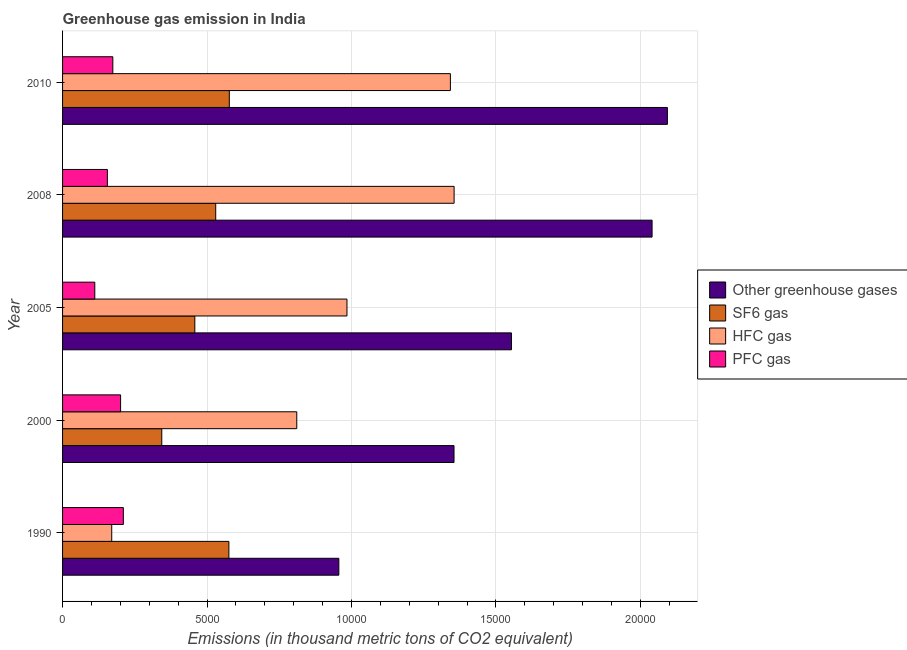What is the emission of sf6 gas in 2008?
Provide a succinct answer. 5301.4. Across all years, what is the maximum emission of pfc gas?
Keep it short and to the point. 2104. Across all years, what is the minimum emission of greenhouse gases?
Ensure brevity in your answer.  9563.6. In which year was the emission of hfc gas maximum?
Your answer should be compact. 2008. In which year was the emission of sf6 gas minimum?
Offer a very short reply. 2000. What is the total emission of sf6 gas in the graph?
Your answer should be very brief. 2.48e+04. What is the difference between the emission of pfc gas in 2000 and that in 2005?
Provide a succinct answer. 893. What is the difference between the emission of sf6 gas in 2000 and the emission of hfc gas in 2008?
Offer a terse response. -1.01e+04. What is the average emission of sf6 gas per year?
Offer a very short reply. 4968.86. In the year 2005, what is the difference between the emission of greenhouse gases and emission of sf6 gas?
Give a very brief answer. 1.10e+04. What is the ratio of the emission of pfc gas in 1990 to that in 2008?
Your response must be concise. 1.36. What is the difference between the highest and the second highest emission of greenhouse gases?
Offer a very short reply. 530.1. What is the difference between the highest and the lowest emission of sf6 gas?
Ensure brevity in your answer.  2337.3. In how many years, is the emission of pfc gas greater than the average emission of pfc gas taken over all years?
Ensure brevity in your answer.  3. Is it the case that in every year, the sum of the emission of pfc gas and emission of hfc gas is greater than the sum of emission of sf6 gas and emission of greenhouse gases?
Give a very brief answer. Yes. What does the 2nd bar from the top in 2010 represents?
Keep it short and to the point. HFC gas. What does the 2nd bar from the bottom in 2000 represents?
Make the answer very short. SF6 gas. How many bars are there?
Your answer should be compact. 20. What is the difference between two consecutive major ticks on the X-axis?
Provide a short and direct response. 5000. How many legend labels are there?
Your response must be concise. 4. How are the legend labels stacked?
Offer a very short reply. Vertical. What is the title of the graph?
Your answer should be compact. Greenhouse gas emission in India. Does "Agriculture" appear as one of the legend labels in the graph?
Make the answer very short. No. What is the label or title of the X-axis?
Provide a short and direct response. Emissions (in thousand metric tons of CO2 equivalent). What is the label or title of the Y-axis?
Your answer should be very brief. Year. What is the Emissions (in thousand metric tons of CO2 equivalent) in Other greenhouse gases in 1990?
Give a very brief answer. 9563.6. What is the Emissions (in thousand metric tons of CO2 equivalent) of SF6 gas in 1990?
Offer a very short reply. 5757.5. What is the Emissions (in thousand metric tons of CO2 equivalent) of HFC gas in 1990?
Provide a succinct answer. 1702.1. What is the Emissions (in thousand metric tons of CO2 equivalent) in PFC gas in 1990?
Ensure brevity in your answer.  2104. What is the Emissions (in thousand metric tons of CO2 equivalent) of Other greenhouse gases in 2000?
Offer a terse response. 1.36e+04. What is the Emissions (in thousand metric tons of CO2 equivalent) of SF6 gas in 2000?
Ensure brevity in your answer.  3434.7. What is the Emissions (in thousand metric tons of CO2 equivalent) of HFC gas in 2000?
Provide a short and direct response. 8107.2. What is the Emissions (in thousand metric tons of CO2 equivalent) in PFC gas in 2000?
Keep it short and to the point. 2008.8. What is the Emissions (in thousand metric tons of CO2 equivalent) of Other greenhouse gases in 2005?
Give a very brief answer. 1.55e+04. What is the Emissions (in thousand metric tons of CO2 equivalent) of SF6 gas in 2005?
Your answer should be compact. 4578.7. What is the Emissions (in thousand metric tons of CO2 equivalent) in HFC gas in 2005?
Provide a short and direct response. 9845.2. What is the Emissions (in thousand metric tons of CO2 equivalent) of PFC gas in 2005?
Your answer should be very brief. 1115.8. What is the Emissions (in thousand metric tons of CO2 equivalent) in Other greenhouse gases in 2008?
Your answer should be compact. 2.04e+04. What is the Emissions (in thousand metric tons of CO2 equivalent) of SF6 gas in 2008?
Keep it short and to the point. 5301.4. What is the Emissions (in thousand metric tons of CO2 equivalent) of HFC gas in 2008?
Provide a succinct answer. 1.36e+04. What is the Emissions (in thousand metric tons of CO2 equivalent) of PFC gas in 2008?
Offer a terse response. 1551.8. What is the Emissions (in thousand metric tons of CO2 equivalent) of Other greenhouse gases in 2010?
Give a very brief answer. 2.09e+04. What is the Emissions (in thousand metric tons of CO2 equivalent) in SF6 gas in 2010?
Ensure brevity in your answer.  5772. What is the Emissions (in thousand metric tons of CO2 equivalent) of HFC gas in 2010?
Offer a very short reply. 1.34e+04. What is the Emissions (in thousand metric tons of CO2 equivalent) in PFC gas in 2010?
Provide a short and direct response. 1740. Across all years, what is the maximum Emissions (in thousand metric tons of CO2 equivalent) in Other greenhouse gases?
Keep it short and to the point. 2.09e+04. Across all years, what is the maximum Emissions (in thousand metric tons of CO2 equivalent) in SF6 gas?
Keep it short and to the point. 5772. Across all years, what is the maximum Emissions (in thousand metric tons of CO2 equivalent) in HFC gas?
Provide a succinct answer. 1.36e+04. Across all years, what is the maximum Emissions (in thousand metric tons of CO2 equivalent) in PFC gas?
Offer a very short reply. 2104. Across all years, what is the minimum Emissions (in thousand metric tons of CO2 equivalent) of Other greenhouse gases?
Provide a short and direct response. 9563.6. Across all years, what is the minimum Emissions (in thousand metric tons of CO2 equivalent) in SF6 gas?
Ensure brevity in your answer.  3434.7. Across all years, what is the minimum Emissions (in thousand metric tons of CO2 equivalent) of HFC gas?
Your answer should be compact. 1702.1. Across all years, what is the minimum Emissions (in thousand metric tons of CO2 equivalent) of PFC gas?
Your answer should be compact. 1115.8. What is the total Emissions (in thousand metric tons of CO2 equivalent) in Other greenhouse gases in the graph?
Give a very brief answer. 8.00e+04. What is the total Emissions (in thousand metric tons of CO2 equivalent) in SF6 gas in the graph?
Give a very brief answer. 2.48e+04. What is the total Emissions (in thousand metric tons of CO2 equivalent) in HFC gas in the graph?
Your answer should be compact. 4.66e+04. What is the total Emissions (in thousand metric tons of CO2 equivalent) of PFC gas in the graph?
Your answer should be compact. 8520.4. What is the difference between the Emissions (in thousand metric tons of CO2 equivalent) of Other greenhouse gases in 1990 and that in 2000?
Give a very brief answer. -3987.1. What is the difference between the Emissions (in thousand metric tons of CO2 equivalent) in SF6 gas in 1990 and that in 2000?
Offer a very short reply. 2322.8. What is the difference between the Emissions (in thousand metric tons of CO2 equivalent) of HFC gas in 1990 and that in 2000?
Your answer should be compact. -6405.1. What is the difference between the Emissions (in thousand metric tons of CO2 equivalent) in PFC gas in 1990 and that in 2000?
Offer a very short reply. 95.2. What is the difference between the Emissions (in thousand metric tons of CO2 equivalent) of Other greenhouse gases in 1990 and that in 2005?
Provide a succinct answer. -5976.1. What is the difference between the Emissions (in thousand metric tons of CO2 equivalent) in SF6 gas in 1990 and that in 2005?
Ensure brevity in your answer.  1178.8. What is the difference between the Emissions (in thousand metric tons of CO2 equivalent) in HFC gas in 1990 and that in 2005?
Offer a very short reply. -8143.1. What is the difference between the Emissions (in thousand metric tons of CO2 equivalent) in PFC gas in 1990 and that in 2005?
Give a very brief answer. 988.2. What is the difference between the Emissions (in thousand metric tons of CO2 equivalent) of Other greenhouse gases in 1990 and that in 2008?
Offer a very short reply. -1.08e+04. What is the difference between the Emissions (in thousand metric tons of CO2 equivalent) in SF6 gas in 1990 and that in 2008?
Provide a short and direct response. 456.1. What is the difference between the Emissions (in thousand metric tons of CO2 equivalent) of HFC gas in 1990 and that in 2008?
Offer a terse response. -1.19e+04. What is the difference between the Emissions (in thousand metric tons of CO2 equivalent) of PFC gas in 1990 and that in 2008?
Your response must be concise. 552.2. What is the difference between the Emissions (in thousand metric tons of CO2 equivalent) in Other greenhouse gases in 1990 and that in 2010?
Give a very brief answer. -1.14e+04. What is the difference between the Emissions (in thousand metric tons of CO2 equivalent) in SF6 gas in 1990 and that in 2010?
Your answer should be very brief. -14.5. What is the difference between the Emissions (in thousand metric tons of CO2 equivalent) in HFC gas in 1990 and that in 2010?
Offer a terse response. -1.17e+04. What is the difference between the Emissions (in thousand metric tons of CO2 equivalent) in PFC gas in 1990 and that in 2010?
Your answer should be very brief. 364. What is the difference between the Emissions (in thousand metric tons of CO2 equivalent) in Other greenhouse gases in 2000 and that in 2005?
Provide a short and direct response. -1989. What is the difference between the Emissions (in thousand metric tons of CO2 equivalent) of SF6 gas in 2000 and that in 2005?
Make the answer very short. -1144. What is the difference between the Emissions (in thousand metric tons of CO2 equivalent) of HFC gas in 2000 and that in 2005?
Give a very brief answer. -1738. What is the difference between the Emissions (in thousand metric tons of CO2 equivalent) of PFC gas in 2000 and that in 2005?
Ensure brevity in your answer.  893. What is the difference between the Emissions (in thousand metric tons of CO2 equivalent) in Other greenhouse gases in 2000 and that in 2008?
Offer a terse response. -6856.2. What is the difference between the Emissions (in thousand metric tons of CO2 equivalent) in SF6 gas in 2000 and that in 2008?
Offer a terse response. -1866.7. What is the difference between the Emissions (in thousand metric tons of CO2 equivalent) in HFC gas in 2000 and that in 2008?
Your response must be concise. -5446.5. What is the difference between the Emissions (in thousand metric tons of CO2 equivalent) in PFC gas in 2000 and that in 2008?
Provide a short and direct response. 457. What is the difference between the Emissions (in thousand metric tons of CO2 equivalent) in Other greenhouse gases in 2000 and that in 2010?
Your response must be concise. -7386.3. What is the difference between the Emissions (in thousand metric tons of CO2 equivalent) of SF6 gas in 2000 and that in 2010?
Keep it short and to the point. -2337.3. What is the difference between the Emissions (in thousand metric tons of CO2 equivalent) in HFC gas in 2000 and that in 2010?
Your answer should be very brief. -5317.8. What is the difference between the Emissions (in thousand metric tons of CO2 equivalent) of PFC gas in 2000 and that in 2010?
Your answer should be very brief. 268.8. What is the difference between the Emissions (in thousand metric tons of CO2 equivalent) in Other greenhouse gases in 2005 and that in 2008?
Offer a very short reply. -4867.2. What is the difference between the Emissions (in thousand metric tons of CO2 equivalent) in SF6 gas in 2005 and that in 2008?
Offer a terse response. -722.7. What is the difference between the Emissions (in thousand metric tons of CO2 equivalent) in HFC gas in 2005 and that in 2008?
Your answer should be very brief. -3708.5. What is the difference between the Emissions (in thousand metric tons of CO2 equivalent) in PFC gas in 2005 and that in 2008?
Your response must be concise. -436. What is the difference between the Emissions (in thousand metric tons of CO2 equivalent) in Other greenhouse gases in 2005 and that in 2010?
Offer a very short reply. -5397.3. What is the difference between the Emissions (in thousand metric tons of CO2 equivalent) in SF6 gas in 2005 and that in 2010?
Provide a short and direct response. -1193.3. What is the difference between the Emissions (in thousand metric tons of CO2 equivalent) of HFC gas in 2005 and that in 2010?
Provide a succinct answer. -3579.8. What is the difference between the Emissions (in thousand metric tons of CO2 equivalent) in PFC gas in 2005 and that in 2010?
Provide a succinct answer. -624.2. What is the difference between the Emissions (in thousand metric tons of CO2 equivalent) of Other greenhouse gases in 2008 and that in 2010?
Your answer should be very brief. -530.1. What is the difference between the Emissions (in thousand metric tons of CO2 equivalent) of SF6 gas in 2008 and that in 2010?
Offer a very short reply. -470.6. What is the difference between the Emissions (in thousand metric tons of CO2 equivalent) in HFC gas in 2008 and that in 2010?
Make the answer very short. 128.7. What is the difference between the Emissions (in thousand metric tons of CO2 equivalent) in PFC gas in 2008 and that in 2010?
Offer a terse response. -188.2. What is the difference between the Emissions (in thousand metric tons of CO2 equivalent) in Other greenhouse gases in 1990 and the Emissions (in thousand metric tons of CO2 equivalent) in SF6 gas in 2000?
Make the answer very short. 6128.9. What is the difference between the Emissions (in thousand metric tons of CO2 equivalent) of Other greenhouse gases in 1990 and the Emissions (in thousand metric tons of CO2 equivalent) of HFC gas in 2000?
Your response must be concise. 1456.4. What is the difference between the Emissions (in thousand metric tons of CO2 equivalent) in Other greenhouse gases in 1990 and the Emissions (in thousand metric tons of CO2 equivalent) in PFC gas in 2000?
Your answer should be compact. 7554.8. What is the difference between the Emissions (in thousand metric tons of CO2 equivalent) of SF6 gas in 1990 and the Emissions (in thousand metric tons of CO2 equivalent) of HFC gas in 2000?
Your response must be concise. -2349.7. What is the difference between the Emissions (in thousand metric tons of CO2 equivalent) in SF6 gas in 1990 and the Emissions (in thousand metric tons of CO2 equivalent) in PFC gas in 2000?
Your response must be concise. 3748.7. What is the difference between the Emissions (in thousand metric tons of CO2 equivalent) of HFC gas in 1990 and the Emissions (in thousand metric tons of CO2 equivalent) of PFC gas in 2000?
Provide a short and direct response. -306.7. What is the difference between the Emissions (in thousand metric tons of CO2 equivalent) of Other greenhouse gases in 1990 and the Emissions (in thousand metric tons of CO2 equivalent) of SF6 gas in 2005?
Offer a very short reply. 4984.9. What is the difference between the Emissions (in thousand metric tons of CO2 equivalent) in Other greenhouse gases in 1990 and the Emissions (in thousand metric tons of CO2 equivalent) in HFC gas in 2005?
Offer a very short reply. -281.6. What is the difference between the Emissions (in thousand metric tons of CO2 equivalent) in Other greenhouse gases in 1990 and the Emissions (in thousand metric tons of CO2 equivalent) in PFC gas in 2005?
Your answer should be very brief. 8447.8. What is the difference between the Emissions (in thousand metric tons of CO2 equivalent) of SF6 gas in 1990 and the Emissions (in thousand metric tons of CO2 equivalent) of HFC gas in 2005?
Offer a very short reply. -4087.7. What is the difference between the Emissions (in thousand metric tons of CO2 equivalent) in SF6 gas in 1990 and the Emissions (in thousand metric tons of CO2 equivalent) in PFC gas in 2005?
Offer a very short reply. 4641.7. What is the difference between the Emissions (in thousand metric tons of CO2 equivalent) in HFC gas in 1990 and the Emissions (in thousand metric tons of CO2 equivalent) in PFC gas in 2005?
Your answer should be very brief. 586.3. What is the difference between the Emissions (in thousand metric tons of CO2 equivalent) in Other greenhouse gases in 1990 and the Emissions (in thousand metric tons of CO2 equivalent) in SF6 gas in 2008?
Provide a succinct answer. 4262.2. What is the difference between the Emissions (in thousand metric tons of CO2 equivalent) in Other greenhouse gases in 1990 and the Emissions (in thousand metric tons of CO2 equivalent) in HFC gas in 2008?
Offer a very short reply. -3990.1. What is the difference between the Emissions (in thousand metric tons of CO2 equivalent) of Other greenhouse gases in 1990 and the Emissions (in thousand metric tons of CO2 equivalent) of PFC gas in 2008?
Keep it short and to the point. 8011.8. What is the difference between the Emissions (in thousand metric tons of CO2 equivalent) in SF6 gas in 1990 and the Emissions (in thousand metric tons of CO2 equivalent) in HFC gas in 2008?
Provide a short and direct response. -7796.2. What is the difference between the Emissions (in thousand metric tons of CO2 equivalent) in SF6 gas in 1990 and the Emissions (in thousand metric tons of CO2 equivalent) in PFC gas in 2008?
Your response must be concise. 4205.7. What is the difference between the Emissions (in thousand metric tons of CO2 equivalent) of HFC gas in 1990 and the Emissions (in thousand metric tons of CO2 equivalent) of PFC gas in 2008?
Keep it short and to the point. 150.3. What is the difference between the Emissions (in thousand metric tons of CO2 equivalent) in Other greenhouse gases in 1990 and the Emissions (in thousand metric tons of CO2 equivalent) in SF6 gas in 2010?
Give a very brief answer. 3791.6. What is the difference between the Emissions (in thousand metric tons of CO2 equivalent) of Other greenhouse gases in 1990 and the Emissions (in thousand metric tons of CO2 equivalent) of HFC gas in 2010?
Your answer should be compact. -3861.4. What is the difference between the Emissions (in thousand metric tons of CO2 equivalent) of Other greenhouse gases in 1990 and the Emissions (in thousand metric tons of CO2 equivalent) of PFC gas in 2010?
Provide a short and direct response. 7823.6. What is the difference between the Emissions (in thousand metric tons of CO2 equivalent) of SF6 gas in 1990 and the Emissions (in thousand metric tons of CO2 equivalent) of HFC gas in 2010?
Ensure brevity in your answer.  -7667.5. What is the difference between the Emissions (in thousand metric tons of CO2 equivalent) in SF6 gas in 1990 and the Emissions (in thousand metric tons of CO2 equivalent) in PFC gas in 2010?
Offer a terse response. 4017.5. What is the difference between the Emissions (in thousand metric tons of CO2 equivalent) of HFC gas in 1990 and the Emissions (in thousand metric tons of CO2 equivalent) of PFC gas in 2010?
Ensure brevity in your answer.  -37.9. What is the difference between the Emissions (in thousand metric tons of CO2 equivalent) in Other greenhouse gases in 2000 and the Emissions (in thousand metric tons of CO2 equivalent) in SF6 gas in 2005?
Provide a succinct answer. 8972. What is the difference between the Emissions (in thousand metric tons of CO2 equivalent) of Other greenhouse gases in 2000 and the Emissions (in thousand metric tons of CO2 equivalent) of HFC gas in 2005?
Keep it short and to the point. 3705.5. What is the difference between the Emissions (in thousand metric tons of CO2 equivalent) of Other greenhouse gases in 2000 and the Emissions (in thousand metric tons of CO2 equivalent) of PFC gas in 2005?
Give a very brief answer. 1.24e+04. What is the difference between the Emissions (in thousand metric tons of CO2 equivalent) in SF6 gas in 2000 and the Emissions (in thousand metric tons of CO2 equivalent) in HFC gas in 2005?
Make the answer very short. -6410.5. What is the difference between the Emissions (in thousand metric tons of CO2 equivalent) of SF6 gas in 2000 and the Emissions (in thousand metric tons of CO2 equivalent) of PFC gas in 2005?
Ensure brevity in your answer.  2318.9. What is the difference between the Emissions (in thousand metric tons of CO2 equivalent) in HFC gas in 2000 and the Emissions (in thousand metric tons of CO2 equivalent) in PFC gas in 2005?
Give a very brief answer. 6991.4. What is the difference between the Emissions (in thousand metric tons of CO2 equivalent) of Other greenhouse gases in 2000 and the Emissions (in thousand metric tons of CO2 equivalent) of SF6 gas in 2008?
Your answer should be very brief. 8249.3. What is the difference between the Emissions (in thousand metric tons of CO2 equivalent) in Other greenhouse gases in 2000 and the Emissions (in thousand metric tons of CO2 equivalent) in PFC gas in 2008?
Make the answer very short. 1.20e+04. What is the difference between the Emissions (in thousand metric tons of CO2 equivalent) of SF6 gas in 2000 and the Emissions (in thousand metric tons of CO2 equivalent) of HFC gas in 2008?
Provide a succinct answer. -1.01e+04. What is the difference between the Emissions (in thousand metric tons of CO2 equivalent) in SF6 gas in 2000 and the Emissions (in thousand metric tons of CO2 equivalent) in PFC gas in 2008?
Provide a short and direct response. 1882.9. What is the difference between the Emissions (in thousand metric tons of CO2 equivalent) in HFC gas in 2000 and the Emissions (in thousand metric tons of CO2 equivalent) in PFC gas in 2008?
Make the answer very short. 6555.4. What is the difference between the Emissions (in thousand metric tons of CO2 equivalent) of Other greenhouse gases in 2000 and the Emissions (in thousand metric tons of CO2 equivalent) of SF6 gas in 2010?
Provide a succinct answer. 7778.7. What is the difference between the Emissions (in thousand metric tons of CO2 equivalent) in Other greenhouse gases in 2000 and the Emissions (in thousand metric tons of CO2 equivalent) in HFC gas in 2010?
Your response must be concise. 125.7. What is the difference between the Emissions (in thousand metric tons of CO2 equivalent) of Other greenhouse gases in 2000 and the Emissions (in thousand metric tons of CO2 equivalent) of PFC gas in 2010?
Ensure brevity in your answer.  1.18e+04. What is the difference between the Emissions (in thousand metric tons of CO2 equivalent) in SF6 gas in 2000 and the Emissions (in thousand metric tons of CO2 equivalent) in HFC gas in 2010?
Ensure brevity in your answer.  -9990.3. What is the difference between the Emissions (in thousand metric tons of CO2 equivalent) in SF6 gas in 2000 and the Emissions (in thousand metric tons of CO2 equivalent) in PFC gas in 2010?
Offer a very short reply. 1694.7. What is the difference between the Emissions (in thousand metric tons of CO2 equivalent) in HFC gas in 2000 and the Emissions (in thousand metric tons of CO2 equivalent) in PFC gas in 2010?
Offer a terse response. 6367.2. What is the difference between the Emissions (in thousand metric tons of CO2 equivalent) in Other greenhouse gases in 2005 and the Emissions (in thousand metric tons of CO2 equivalent) in SF6 gas in 2008?
Your response must be concise. 1.02e+04. What is the difference between the Emissions (in thousand metric tons of CO2 equivalent) in Other greenhouse gases in 2005 and the Emissions (in thousand metric tons of CO2 equivalent) in HFC gas in 2008?
Offer a terse response. 1986. What is the difference between the Emissions (in thousand metric tons of CO2 equivalent) of Other greenhouse gases in 2005 and the Emissions (in thousand metric tons of CO2 equivalent) of PFC gas in 2008?
Your answer should be compact. 1.40e+04. What is the difference between the Emissions (in thousand metric tons of CO2 equivalent) in SF6 gas in 2005 and the Emissions (in thousand metric tons of CO2 equivalent) in HFC gas in 2008?
Your answer should be very brief. -8975. What is the difference between the Emissions (in thousand metric tons of CO2 equivalent) in SF6 gas in 2005 and the Emissions (in thousand metric tons of CO2 equivalent) in PFC gas in 2008?
Your response must be concise. 3026.9. What is the difference between the Emissions (in thousand metric tons of CO2 equivalent) in HFC gas in 2005 and the Emissions (in thousand metric tons of CO2 equivalent) in PFC gas in 2008?
Make the answer very short. 8293.4. What is the difference between the Emissions (in thousand metric tons of CO2 equivalent) of Other greenhouse gases in 2005 and the Emissions (in thousand metric tons of CO2 equivalent) of SF6 gas in 2010?
Your answer should be compact. 9767.7. What is the difference between the Emissions (in thousand metric tons of CO2 equivalent) in Other greenhouse gases in 2005 and the Emissions (in thousand metric tons of CO2 equivalent) in HFC gas in 2010?
Keep it short and to the point. 2114.7. What is the difference between the Emissions (in thousand metric tons of CO2 equivalent) of Other greenhouse gases in 2005 and the Emissions (in thousand metric tons of CO2 equivalent) of PFC gas in 2010?
Your answer should be compact. 1.38e+04. What is the difference between the Emissions (in thousand metric tons of CO2 equivalent) of SF6 gas in 2005 and the Emissions (in thousand metric tons of CO2 equivalent) of HFC gas in 2010?
Provide a short and direct response. -8846.3. What is the difference between the Emissions (in thousand metric tons of CO2 equivalent) in SF6 gas in 2005 and the Emissions (in thousand metric tons of CO2 equivalent) in PFC gas in 2010?
Provide a succinct answer. 2838.7. What is the difference between the Emissions (in thousand metric tons of CO2 equivalent) in HFC gas in 2005 and the Emissions (in thousand metric tons of CO2 equivalent) in PFC gas in 2010?
Make the answer very short. 8105.2. What is the difference between the Emissions (in thousand metric tons of CO2 equivalent) in Other greenhouse gases in 2008 and the Emissions (in thousand metric tons of CO2 equivalent) in SF6 gas in 2010?
Your answer should be compact. 1.46e+04. What is the difference between the Emissions (in thousand metric tons of CO2 equivalent) of Other greenhouse gases in 2008 and the Emissions (in thousand metric tons of CO2 equivalent) of HFC gas in 2010?
Offer a very short reply. 6981.9. What is the difference between the Emissions (in thousand metric tons of CO2 equivalent) in Other greenhouse gases in 2008 and the Emissions (in thousand metric tons of CO2 equivalent) in PFC gas in 2010?
Provide a short and direct response. 1.87e+04. What is the difference between the Emissions (in thousand metric tons of CO2 equivalent) in SF6 gas in 2008 and the Emissions (in thousand metric tons of CO2 equivalent) in HFC gas in 2010?
Provide a succinct answer. -8123.6. What is the difference between the Emissions (in thousand metric tons of CO2 equivalent) of SF6 gas in 2008 and the Emissions (in thousand metric tons of CO2 equivalent) of PFC gas in 2010?
Offer a terse response. 3561.4. What is the difference between the Emissions (in thousand metric tons of CO2 equivalent) of HFC gas in 2008 and the Emissions (in thousand metric tons of CO2 equivalent) of PFC gas in 2010?
Provide a short and direct response. 1.18e+04. What is the average Emissions (in thousand metric tons of CO2 equivalent) in Other greenhouse gases per year?
Offer a very short reply. 1.60e+04. What is the average Emissions (in thousand metric tons of CO2 equivalent) of SF6 gas per year?
Your answer should be very brief. 4968.86. What is the average Emissions (in thousand metric tons of CO2 equivalent) in HFC gas per year?
Your answer should be very brief. 9326.64. What is the average Emissions (in thousand metric tons of CO2 equivalent) of PFC gas per year?
Provide a short and direct response. 1704.08. In the year 1990, what is the difference between the Emissions (in thousand metric tons of CO2 equivalent) of Other greenhouse gases and Emissions (in thousand metric tons of CO2 equivalent) of SF6 gas?
Give a very brief answer. 3806.1. In the year 1990, what is the difference between the Emissions (in thousand metric tons of CO2 equivalent) in Other greenhouse gases and Emissions (in thousand metric tons of CO2 equivalent) in HFC gas?
Make the answer very short. 7861.5. In the year 1990, what is the difference between the Emissions (in thousand metric tons of CO2 equivalent) of Other greenhouse gases and Emissions (in thousand metric tons of CO2 equivalent) of PFC gas?
Offer a very short reply. 7459.6. In the year 1990, what is the difference between the Emissions (in thousand metric tons of CO2 equivalent) in SF6 gas and Emissions (in thousand metric tons of CO2 equivalent) in HFC gas?
Offer a terse response. 4055.4. In the year 1990, what is the difference between the Emissions (in thousand metric tons of CO2 equivalent) of SF6 gas and Emissions (in thousand metric tons of CO2 equivalent) of PFC gas?
Offer a terse response. 3653.5. In the year 1990, what is the difference between the Emissions (in thousand metric tons of CO2 equivalent) of HFC gas and Emissions (in thousand metric tons of CO2 equivalent) of PFC gas?
Provide a short and direct response. -401.9. In the year 2000, what is the difference between the Emissions (in thousand metric tons of CO2 equivalent) of Other greenhouse gases and Emissions (in thousand metric tons of CO2 equivalent) of SF6 gas?
Your answer should be very brief. 1.01e+04. In the year 2000, what is the difference between the Emissions (in thousand metric tons of CO2 equivalent) of Other greenhouse gases and Emissions (in thousand metric tons of CO2 equivalent) of HFC gas?
Your answer should be compact. 5443.5. In the year 2000, what is the difference between the Emissions (in thousand metric tons of CO2 equivalent) in Other greenhouse gases and Emissions (in thousand metric tons of CO2 equivalent) in PFC gas?
Your response must be concise. 1.15e+04. In the year 2000, what is the difference between the Emissions (in thousand metric tons of CO2 equivalent) of SF6 gas and Emissions (in thousand metric tons of CO2 equivalent) of HFC gas?
Make the answer very short. -4672.5. In the year 2000, what is the difference between the Emissions (in thousand metric tons of CO2 equivalent) in SF6 gas and Emissions (in thousand metric tons of CO2 equivalent) in PFC gas?
Offer a very short reply. 1425.9. In the year 2000, what is the difference between the Emissions (in thousand metric tons of CO2 equivalent) of HFC gas and Emissions (in thousand metric tons of CO2 equivalent) of PFC gas?
Give a very brief answer. 6098.4. In the year 2005, what is the difference between the Emissions (in thousand metric tons of CO2 equivalent) of Other greenhouse gases and Emissions (in thousand metric tons of CO2 equivalent) of SF6 gas?
Keep it short and to the point. 1.10e+04. In the year 2005, what is the difference between the Emissions (in thousand metric tons of CO2 equivalent) in Other greenhouse gases and Emissions (in thousand metric tons of CO2 equivalent) in HFC gas?
Keep it short and to the point. 5694.5. In the year 2005, what is the difference between the Emissions (in thousand metric tons of CO2 equivalent) of Other greenhouse gases and Emissions (in thousand metric tons of CO2 equivalent) of PFC gas?
Your answer should be very brief. 1.44e+04. In the year 2005, what is the difference between the Emissions (in thousand metric tons of CO2 equivalent) of SF6 gas and Emissions (in thousand metric tons of CO2 equivalent) of HFC gas?
Offer a terse response. -5266.5. In the year 2005, what is the difference between the Emissions (in thousand metric tons of CO2 equivalent) of SF6 gas and Emissions (in thousand metric tons of CO2 equivalent) of PFC gas?
Your response must be concise. 3462.9. In the year 2005, what is the difference between the Emissions (in thousand metric tons of CO2 equivalent) in HFC gas and Emissions (in thousand metric tons of CO2 equivalent) in PFC gas?
Offer a very short reply. 8729.4. In the year 2008, what is the difference between the Emissions (in thousand metric tons of CO2 equivalent) of Other greenhouse gases and Emissions (in thousand metric tons of CO2 equivalent) of SF6 gas?
Your answer should be very brief. 1.51e+04. In the year 2008, what is the difference between the Emissions (in thousand metric tons of CO2 equivalent) in Other greenhouse gases and Emissions (in thousand metric tons of CO2 equivalent) in HFC gas?
Make the answer very short. 6853.2. In the year 2008, what is the difference between the Emissions (in thousand metric tons of CO2 equivalent) of Other greenhouse gases and Emissions (in thousand metric tons of CO2 equivalent) of PFC gas?
Your answer should be very brief. 1.89e+04. In the year 2008, what is the difference between the Emissions (in thousand metric tons of CO2 equivalent) of SF6 gas and Emissions (in thousand metric tons of CO2 equivalent) of HFC gas?
Offer a very short reply. -8252.3. In the year 2008, what is the difference between the Emissions (in thousand metric tons of CO2 equivalent) in SF6 gas and Emissions (in thousand metric tons of CO2 equivalent) in PFC gas?
Your answer should be compact. 3749.6. In the year 2008, what is the difference between the Emissions (in thousand metric tons of CO2 equivalent) in HFC gas and Emissions (in thousand metric tons of CO2 equivalent) in PFC gas?
Provide a succinct answer. 1.20e+04. In the year 2010, what is the difference between the Emissions (in thousand metric tons of CO2 equivalent) in Other greenhouse gases and Emissions (in thousand metric tons of CO2 equivalent) in SF6 gas?
Your response must be concise. 1.52e+04. In the year 2010, what is the difference between the Emissions (in thousand metric tons of CO2 equivalent) in Other greenhouse gases and Emissions (in thousand metric tons of CO2 equivalent) in HFC gas?
Offer a very short reply. 7512. In the year 2010, what is the difference between the Emissions (in thousand metric tons of CO2 equivalent) in Other greenhouse gases and Emissions (in thousand metric tons of CO2 equivalent) in PFC gas?
Your response must be concise. 1.92e+04. In the year 2010, what is the difference between the Emissions (in thousand metric tons of CO2 equivalent) in SF6 gas and Emissions (in thousand metric tons of CO2 equivalent) in HFC gas?
Give a very brief answer. -7653. In the year 2010, what is the difference between the Emissions (in thousand metric tons of CO2 equivalent) of SF6 gas and Emissions (in thousand metric tons of CO2 equivalent) of PFC gas?
Give a very brief answer. 4032. In the year 2010, what is the difference between the Emissions (in thousand metric tons of CO2 equivalent) of HFC gas and Emissions (in thousand metric tons of CO2 equivalent) of PFC gas?
Provide a short and direct response. 1.17e+04. What is the ratio of the Emissions (in thousand metric tons of CO2 equivalent) of Other greenhouse gases in 1990 to that in 2000?
Provide a succinct answer. 0.71. What is the ratio of the Emissions (in thousand metric tons of CO2 equivalent) of SF6 gas in 1990 to that in 2000?
Your answer should be compact. 1.68. What is the ratio of the Emissions (in thousand metric tons of CO2 equivalent) of HFC gas in 1990 to that in 2000?
Make the answer very short. 0.21. What is the ratio of the Emissions (in thousand metric tons of CO2 equivalent) in PFC gas in 1990 to that in 2000?
Your answer should be very brief. 1.05. What is the ratio of the Emissions (in thousand metric tons of CO2 equivalent) in Other greenhouse gases in 1990 to that in 2005?
Give a very brief answer. 0.62. What is the ratio of the Emissions (in thousand metric tons of CO2 equivalent) in SF6 gas in 1990 to that in 2005?
Your response must be concise. 1.26. What is the ratio of the Emissions (in thousand metric tons of CO2 equivalent) in HFC gas in 1990 to that in 2005?
Your answer should be very brief. 0.17. What is the ratio of the Emissions (in thousand metric tons of CO2 equivalent) in PFC gas in 1990 to that in 2005?
Keep it short and to the point. 1.89. What is the ratio of the Emissions (in thousand metric tons of CO2 equivalent) of Other greenhouse gases in 1990 to that in 2008?
Provide a succinct answer. 0.47. What is the ratio of the Emissions (in thousand metric tons of CO2 equivalent) of SF6 gas in 1990 to that in 2008?
Make the answer very short. 1.09. What is the ratio of the Emissions (in thousand metric tons of CO2 equivalent) of HFC gas in 1990 to that in 2008?
Give a very brief answer. 0.13. What is the ratio of the Emissions (in thousand metric tons of CO2 equivalent) of PFC gas in 1990 to that in 2008?
Provide a short and direct response. 1.36. What is the ratio of the Emissions (in thousand metric tons of CO2 equivalent) in Other greenhouse gases in 1990 to that in 2010?
Offer a very short reply. 0.46. What is the ratio of the Emissions (in thousand metric tons of CO2 equivalent) of SF6 gas in 1990 to that in 2010?
Offer a terse response. 1. What is the ratio of the Emissions (in thousand metric tons of CO2 equivalent) of HFC gas in 1990 to that in 2010?
Provide a short and direct response. 0.13. What is the ratio of the Emissions (in thousand metric tons of CO2 equivalent) in PFC gas in 1990 to that in 2010?
Offer a terse response. 1.21. What is the ratio of the Emissions (in thousand metric tons of CO2 equivalent) in Other greenhouse gases in 2000 to that in 2005?
Provide a succinct answer. 0.87. What is the ratio of the Emissions (in thousand metric tons of CO2 equivalent) of SF6 gas in 2000 to that in 2005?
Provide a succinct answer. 0.75. What is the ratio of the Emissions (in thousand metric tons of CO2 equivalent) of HFC gas in 2000 to that in 2005?
Your response must be concise. 0.82. What is the ratio of the Emissions (in thousand metric tons of CO2 equivalent) of PFC gas in 2000 to that in 2005?
Your response must be concise. 1.8. What is the ratio of the Emissions (in thousand metric tons of CO2 equivalent) of Other greenhouse gases in 2000 to that in 2008?
Give a very brief answer. 0.66. What is the ratio of the Emissions (in thousand metric tons of CO2 equivalent) in SF6 gas in 2000 to that in 2008?
Give a very brief answer. 0.65. What is the ratio of the Emissions (in thousand metric tons of CO2 equivalent) of HFC gas in 2000 to that in 2008?
Your answer should be compact. 0.6. What is the ratio of the Emissions (in thousand metric tons of CO2 equivalent) in PFC gas in 2000 to that in 2008?
Make the answer very short. 1.29. What is the ratio of the Emissions (in thousand metric tons of CO2 equivalent) in Other greenhouse gases in 2000 to that in 2010?
Offer a terse response. 0.65. What is the ratio of the Emissions (in thousand metric tons of CO2 equivalent) in SF6 gas in 2000 to that in 2010?
Give a very brief answer. 0.6. What is the ratio of the Emissions (in thousand metric tons of CO2 equivalent) in HFC gas in 2000 to that in 2010?
Your answer should be very brief. 0.6. What is the ratio of the Emissions (in thousand metric tons of CO2 equivalent) in PFC gas in 2000 to that in 2010?
Your answer should be compact. 1.15. What is the ratio of the Emissions (in thousand metric tons of CO2 equivalent) of Other greenhouse gases in 2005 to that in 2008?
Provide a succinct answer. 0.76. What is the ratio of the Emissions (in thousand metric tons of CO2 equivalent) of SF6 gas in 2005 to that in 2008?
Offer a terse response. 0.86. What is the ratio of the Emissions (in thousand metric tons of CO2 equivalent) of HFC gas in 2005 to that in 2008?
Your answer should be very brief. 0.73. What is the ratio of the Emissions (in thousand metric tons of CO2 equivalent) in PFC gas in 2005 to that in 2008?
Provide a short and direct response. 0.72. What is the ratio of the Emissions (in thousand metric tons of CO2 equivalent) in Other greenhouse gases in 2005 to that in 2010?
Your answer should be compact. 0.74. What is the ratio of the Emissions (in thousand metric tons of CO2 equivalent) in SF6 gas in 2005 to that in 2010?
Provide a succinct answer. 0.79. What is the ratio of the Emissions (in thousand metric tons of CO2 equivalent) of HFC gas in 2005 to that in 2010?
Offer a very short reply. 0.73. What is the ratio of the Emissions (in thousand metric tons of CO2 equivalent) of PFC gas in 2005 to that in 2010?
Your answer should be very brief. 0.64. What is the ratio of the Emissions (in thousand metric tons of CO2 equivalent) of Other greenhouse gases in 2008 to that in 2010?
Offer a very short reply. 0.97. What is the ratio of the Emissions (in thousand metric tons of CO2 equivalent) of SF6 gas in 2008 to that in 2010?
Offer a terse response. 0.92. What is the ratio of the Emissions (in thousand metric tons of CO2 equivalent) of HFC gas in 2008 to that in 2010?
Your answer should be compact. 1.01. What is the ratio of the Emissions (in thousand metric tons of CO2 equivalent) of PFC gas in 2008 to that in 2010?
Make the answer very short. 0.89. What is the difference between the highest and the second highest Emissions (in thousand metric tons of CO2 equivalent) in Other greenhouse gases?
Your answer should be very brief. 530.1. What is the difference between the highest and the second highest Emissions (in thousand metric tons of CO2 equivalent) in HFC gas?
Provide a succinct answer. 128.7. What is the difference between the highest and the second highest Emissions (in thousand metric tons of CO2 equivalent) in PFC gas?
Make the answer very short. 95.2. What is the difference between the highest and the lowest Emissions (in thousand metric tons of CO2 equivalent) in Other greenhouse gases?
Provide a succinct answer. 1.14e+04. What is the difference between the highest and the lowest Emissions (in thousand metric tons of CO2 equivalent) in SF6 gas?
Make the answer very short. 2337.3. What is the difference between the highest and the lowest Emissions (in thousand metric tons of CO2 equivalent) of HFC gas?
Your answer should be very brief. 1.19e+04. What is the difference between the highest and the lowest Emissions (in thousand metric tons of CO2 equivalent) in PFC gas?
Offer a very short reply. 988.2. 